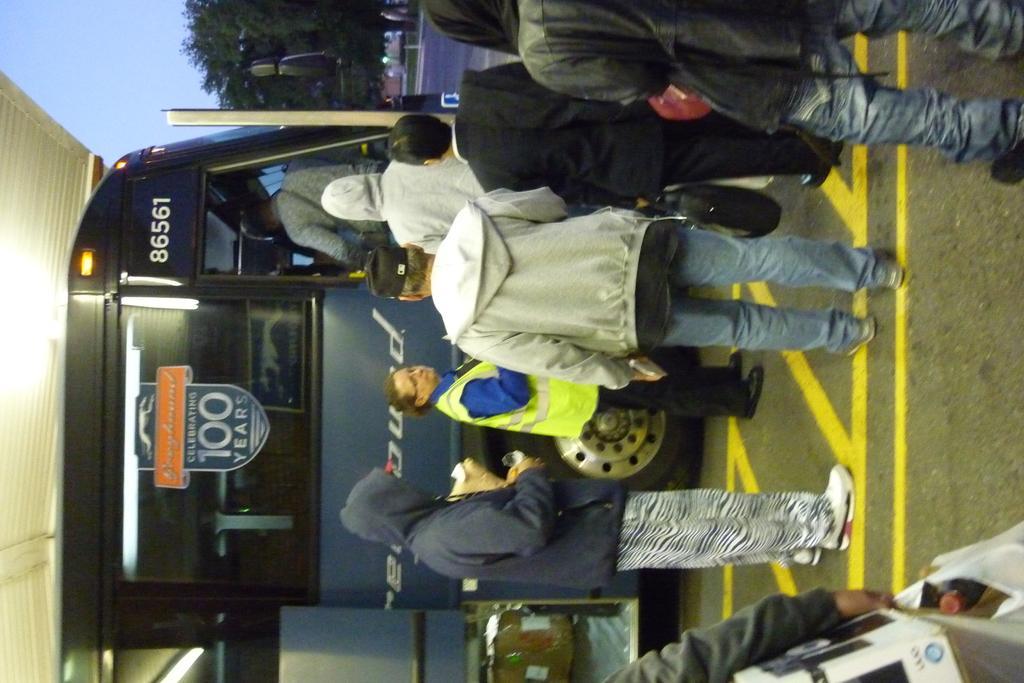How would you summarize this image in a sentence or two? In this image we can see one bus with text, one poster attached to the bus mirror, some people standing on the road, one box in the bus, one blue board, some lights attached to the bus, one shed, some trees, some people walking, one person hand holding some objects, some grass on the ground, some objects on the ground and at the top there is the sky. 